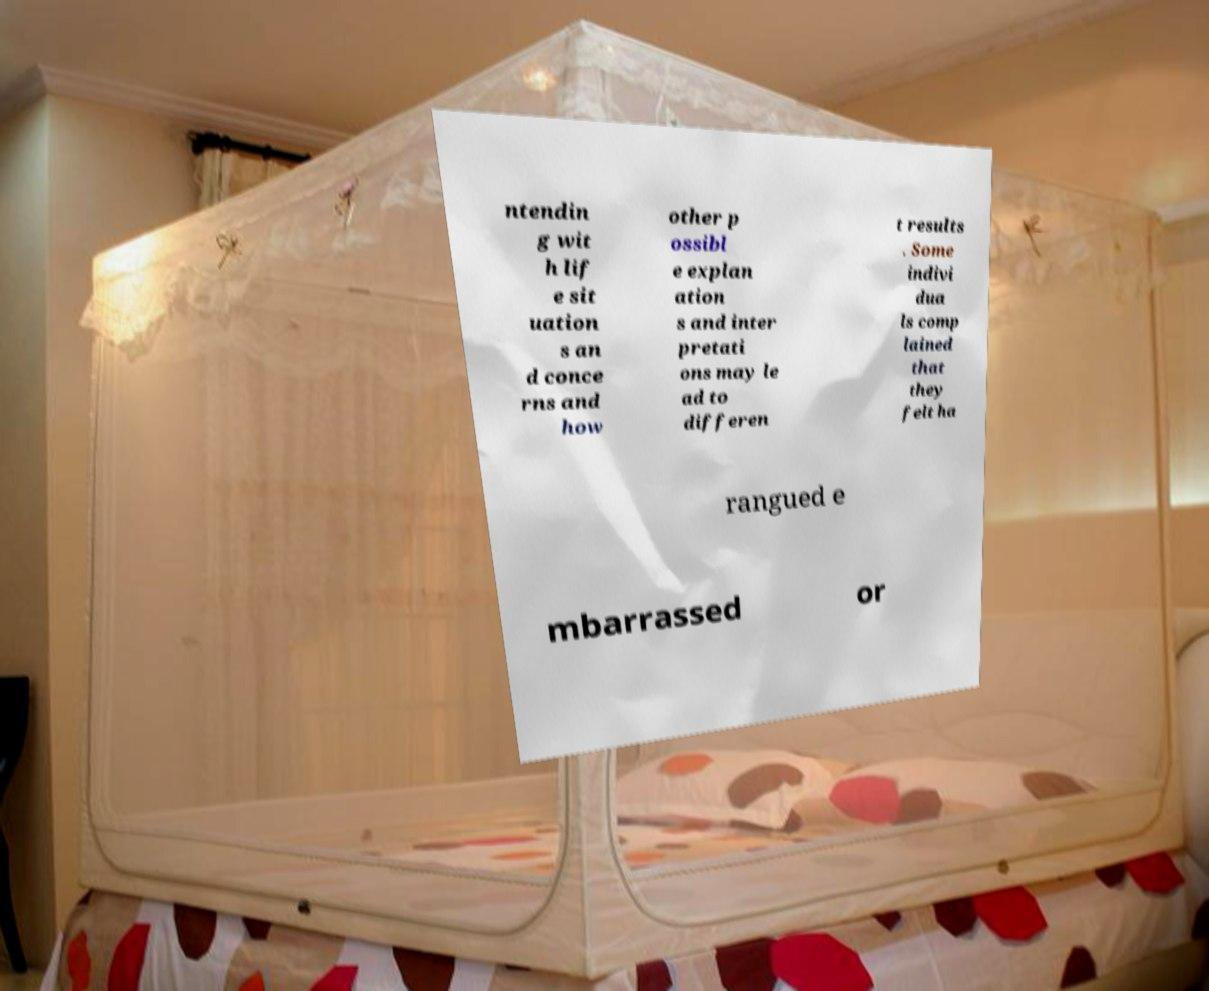Please read and relay the text visible in this image. What does it say? ntendin g wit h lif e sit uation s an d conce rns and how other p ossibl e explan ation s and inter pretati ons may le ad to differen t results . Some indivi dua ls comp lained that they felt ha rangued e mbarrassed or 